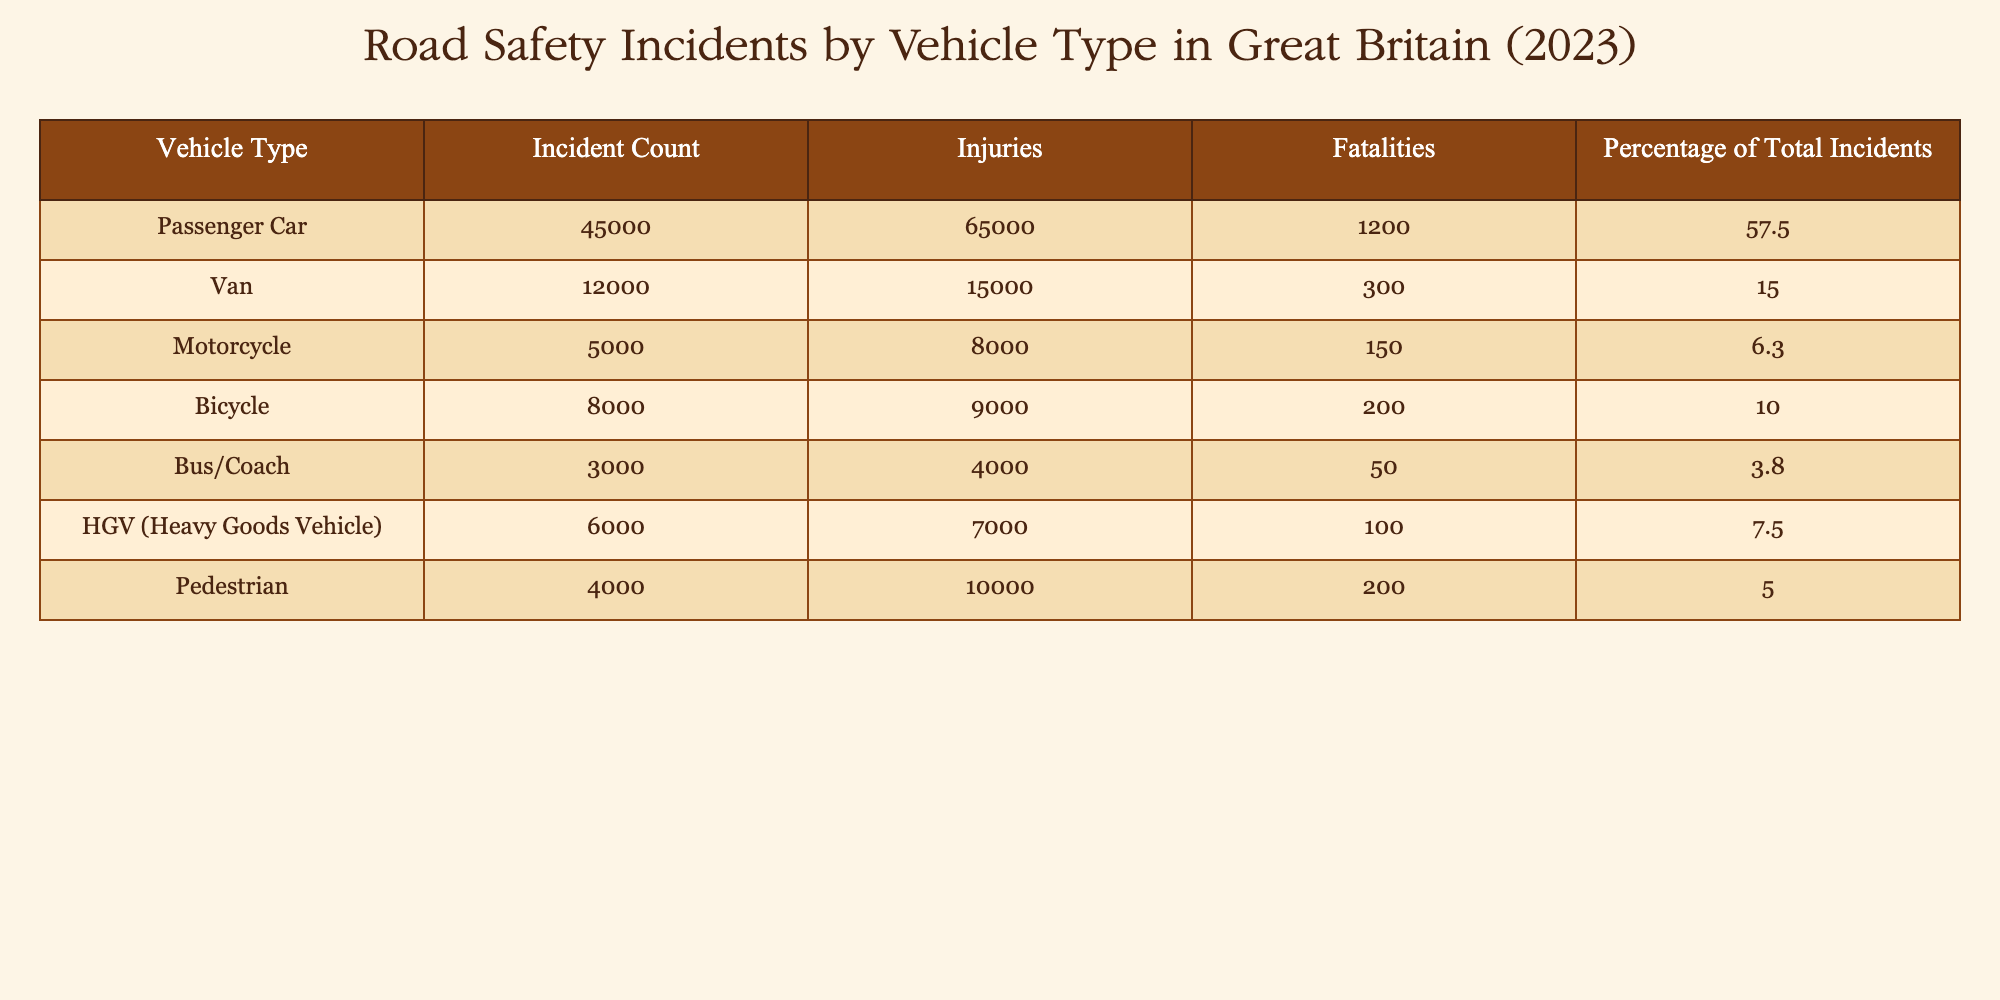What is the total number of incidents involving passenger cars? The table indicates that there are 45,000 incidents involving passenger cars, shown in the "Incident Count" column under "Passenger Car."
Answer: 45000 Which vehicle type had the highest number of fatalities? By examining the "Fatalities" column, passenger cars have 1,200 fatalities, which is more than any other vehicle type. The next closest is the van with 300 fatalities.
Answer: Passenger Car Is the percentage of total incidents involving bicycles greater than that of heavy goods vehicles? The percentage of total incidents involving bicycles is 10.0%, while for heavy goods vehicles, it is 7.5%. Since 10.0% is greater than 7.5%, the statement is true.
Answer: Yes What is the combined total of injuries for vans and buses/coaches? From the table, vans have 15,000 injuries and buses/coaches have 4,000 injuries. Adding these together gives 15,000 + 4,000 = 19,000 injuries.
Answer: 19000 How many total fatalities were recorded for all vehicle types except motorcycles? The total fatalities for all vehicle types are calculated by adding the fatalities of each type: 1200 (cars) + 300 (vans) + 200 (bicycles) + 50 (buses) + 100 (HGVs) + 200 (pedestrians) = 2050. Thus, total fatalities excluding motorcycles (150) is 2050.
Answer: 2050 Does a higher number of injuries correlate with a higher number of incidents for all vehicle types? To determine if there is a correlation, I'll analyze the "Incident Count" and "Injuries" columns. In most cases, such as passenger cars, higher incidents coincide with higher injuries. However, the motorcycle category has fewer incidents but still a notable number of injuries. Thus, while generally true, it's not absolute.
Answer: No What percentage of total incidents do pedestrians represent, and how does it compare to motorcycles? Pedestrians represent 5.0% of total incidents, whereas motorcycles account for 6.3%. Comparing these percentages shows that motorcycles have a higher representation of total incidents than pedestrians.
Answer: Motorcycles What is the average number of injuries per vehicle type in the table? First, I sum the total injuries from each vehicle type: 65000 (cars) + 15000 (vans) + 8000 (motorcycles) + 9000 (bicycles) + 4000 (buses) + 7000 (HGVs) + 10000 (pedestrians) = 107,000. There are 7 vehicle types, so the average is 107,000 divided by 7, which equals approximately 15,286 injuries per vehicle type.
Answer: 15286 